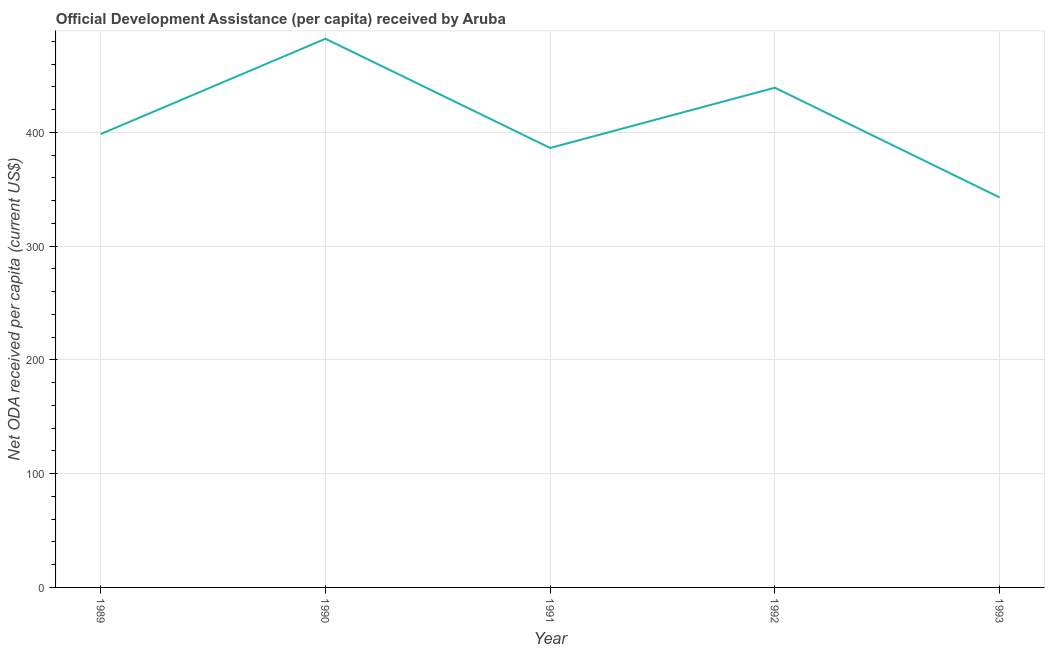What is the net oda received per capita in 1989?
Keep it short and to the point. 398.64. Across all years, what is the maximum net oda received per capita?
Make the answer very short. 482.4. Across all years, what is the minimum net oda received per capita?
Make the answer very short. 342.91. In which year was the net oda received per capita minimum?
Provide a short and direct response. 1993. What is the sum of the net oda received per capita?
Your answer should be very brief. 2049.71. What is the difference between the net oda received per capita in 1989 and 1990?
Offer a terse response. -83.75. What is the average net oda received per capita per year?
Ensure brevity in your answer.  409.94. What is the median net oda received per capita?
Ensure brevity in your answer.  398.64. Do a majority of the years between 1993 and 1992 (inclusive) have net oda received per capita greater than 380 US$?
Your response must be concise. No. What is the ratio of the net oda received per capita in 1989 to that in 1991?
Keep it short and to the point. 1.03. Is the net oda received per capita in 1989 less than that in 1993?
Your answer should be very brief. No. Is the difference between the net oda received per capita in 1990 and 1992 greater than the difference between any two years?
Ensure brevity in your answer.  No. What is the difference between the highest and the second highest net oda received per capita?
Offer a very short reply. 43.03. What is the difference between the highest and the lowest net oda received per capita?
Your answer should be compact. 139.49. In how many years, is the net oda received per capita greater than the average net oda received per capita taken over all years?
Your answer should be very brief. 2. How many lines are there?
Your answer should be compact. 1. How many years are there in the graph?
Your answer should be very brief. 5. Are the values on the major ticks of Y-axis written in scientific E-notation?
Give a very brief answer. No. What is the title of the graph?
Provide a short and direct response. Official Development Assistance (per capita) received by Aruba. What is the label or title of the Y-axis?
Your answer should be very brief. Net ODA received per capita (current US$). What is the Net ODA received per capita (current US$) in 1989?
Your answer should be compact. 398.64. What is the Net ODA received per capita (current US$) in 1990?
Your answer should be compact. 482.4. What is the Net ODA received per capita (current US$) of 1991?
Provide a short and direct response. 386.39. What is the Net ODA received per capita (current US$) of 1992?
Provide a succinct answer. 439.36. What is the Net ODA received per capita (current US$) of 1993?
Offer a very short reply. 342.91. What is the difference between the Net ODA received per capita (current US$) in 1989 and 1990?
Your answer should be compact. -83.75. What is the difference between the Net ODA received per capita (current US$) in 1989 and 1991?
Provide a succinct answer. 12.25. What is the difference between the Net ODA received per capita (current US$) in 1989 and 1992?
Ensure brevity in your answer.  -40.72. What is the difference between the Net ODA received per capita (current US$) in 1989 and 1993?
Offer a terse response. 55.74. What is the difference between the Net ODA received per capita (current US$) in 1990 and 1991?
Give a very brief answer. 96. What is the difference between the Net ODA received per capita (current US$) in 1990 and 1992?
Your answer should be compact. 43.03. What is the difference between the Net ODA received per capita (current US$) in 1990 and 1993?
Offer a terse response. 139.49. What is the difference between the Net ODA received per capita (current US$) in 1991 and 1992?
Your answer should be very brief. -52.97. What is the difference between the Net ODA received per capita (current US$) in 1991 and 1993?
Keep it short and to the point. 43.49. What is the difference between the Net ODA received per capita (current US$) in 1992 and 1993?
Make the answer very short. 96.46. What is the ratio of the Net ODA received per capita (current US$) in 1989 to that in 1990?
Your response must be concise. 0.83. What is the ratio of the Net ODA received per capita (current US$) in 1989 to that in 1991?
Provide a short and direct response. 1.03. What is the ratio of the Net ODA received per capita (current US$) in 1989 to that in 1992?
Keep it short and to the point. 0.91. What is the ratio of the Net ODA received per capita (current US$) in 1989 to that in 1993?
Your answer should be very brief. 1.16. What is the ratio of the Net ODA received per capita (current US$) in 1990 to that in 1991?
Your response must be concise. 1.25. What is the ratio of the Net ODA received per capita (current US$) in 1990 to that in 1992?
Keep it short and to the point. 1.1. What is the ratio of the Net ODA received per capita (current US$) in 1990 to that in 1993?
Offer a terse response. 1.41. What is the ratio of the Net ODA received per capita (current US$) in 1991 to that in 1992?
Your answer should be compact. 0.88. What is the ratio of the Net ODA received per capita (current US$) in 1991 to that in 1993?
Give a very brief answer. 1.13. What is the ratio of the Net ODA received per capita (current US$) in 1992 to that in 1993?
Provide a succinct answer. 1.28. 